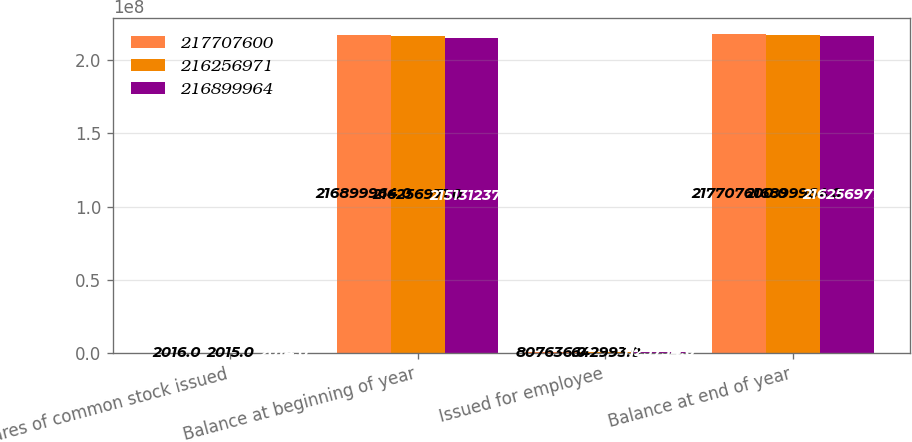Convert chart. <chart><loc_0><loc_0><loc_500><loc_500><stacked_bar_chart><ecel><fcel>Shares of common stock issued<fcel>Balance at beginning of year<fcel>Issued for employee<fcel>Balance at end of year<nl><fcel>2.17708e+08<fcel>2016<fcel>2.169e+08<fcel>807636<fcel>2.17708e+08<nl><fcel>2.16257e+08<fcel>2015<fcel>2.16257e+08<fcel>642993<fcel>2.169e+08<nl><fcel>2.169e+08<fcel>2014<fcel>2.15131e+08<fcel>1.12573e+06<fcel>2.16257e+08<nl></chart> 